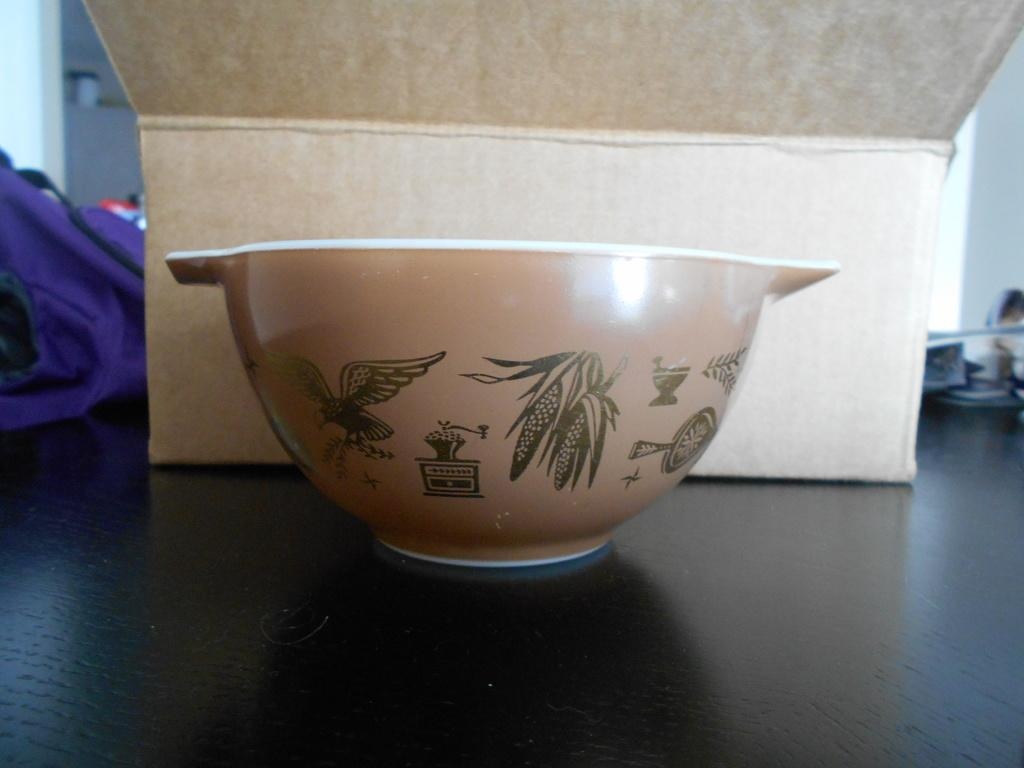What object in the image is pale brown in color? The bowl in the image is pale brown in color. What can be seen on the surface of the bowl? There is a design on the bowl. What other object can be seen in the image besides the bowl? There is a carton box in the image. What is the color of the surface that the bowl and carton box are placed on? The surface is black in color. How many brothers are depicted in the image? There are no people, let alone brothers, depicted in the image. Is there a gun visible in the image? There is no gun present in the image. 